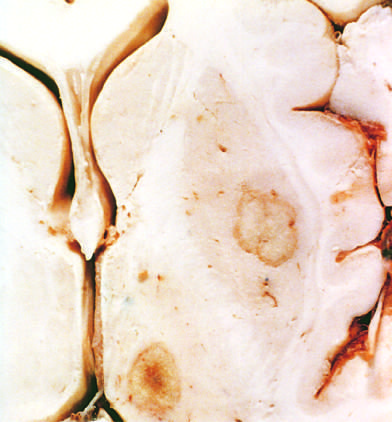what are present in the putamen and thalamus?
Answer the question using a single word or phrase. Abscesses 